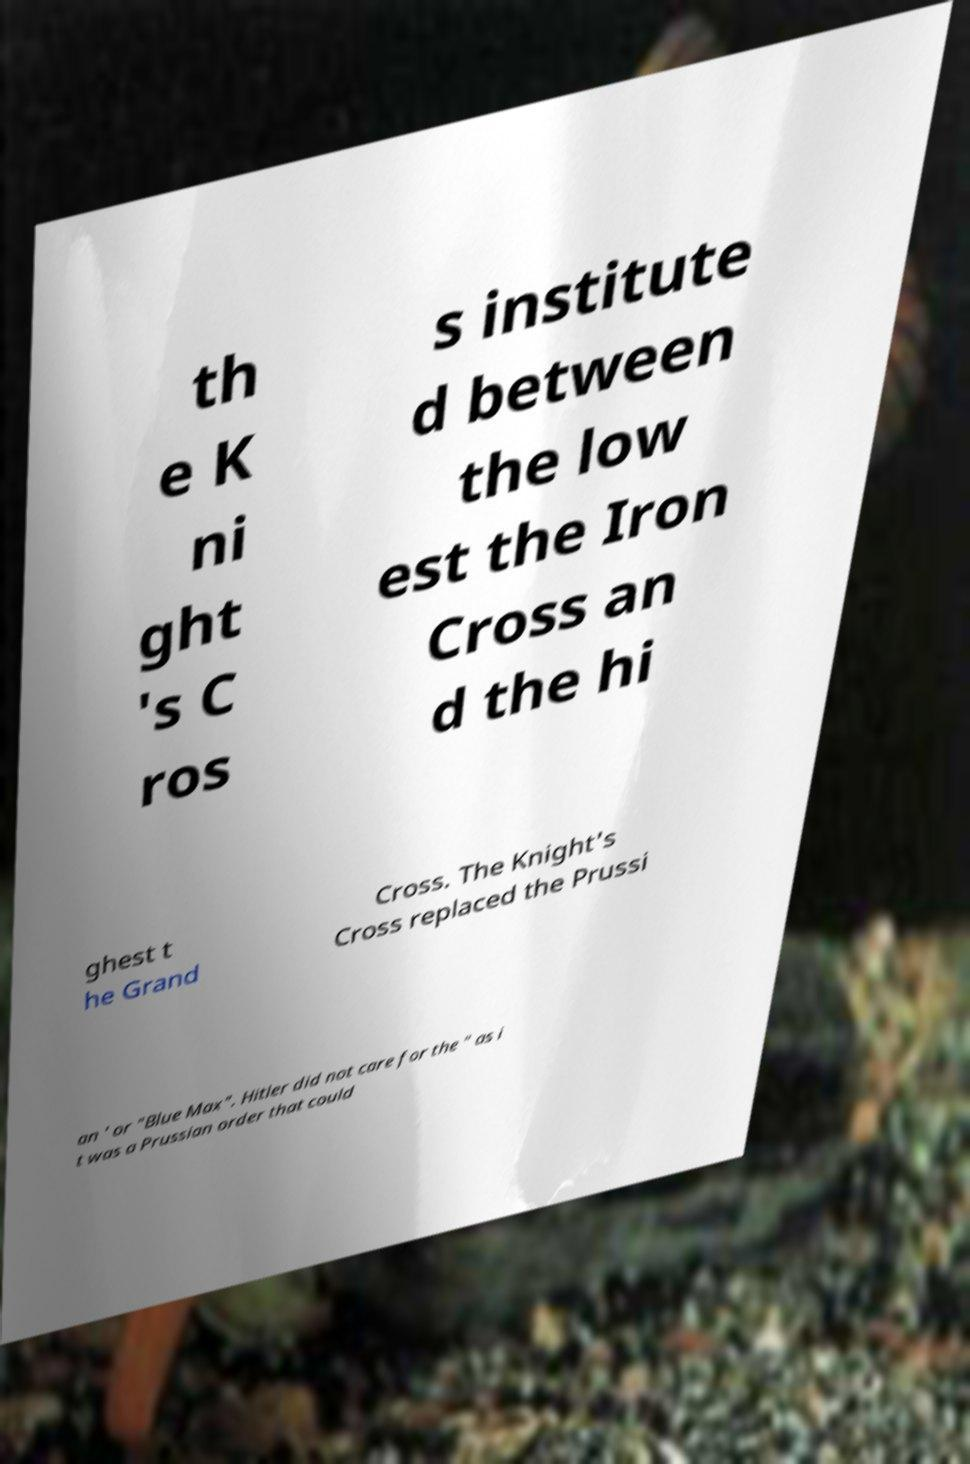Could you extract and type out the text from this image? th e K ni ght 's C ros s institute d between the low est the Iron Cross an d the hi ghest t he Grand Cross. The Knight's Cross replaced the Prussi an ' or "Blue Max". Hitler did not care for the " as i t was a Prussian order that could 